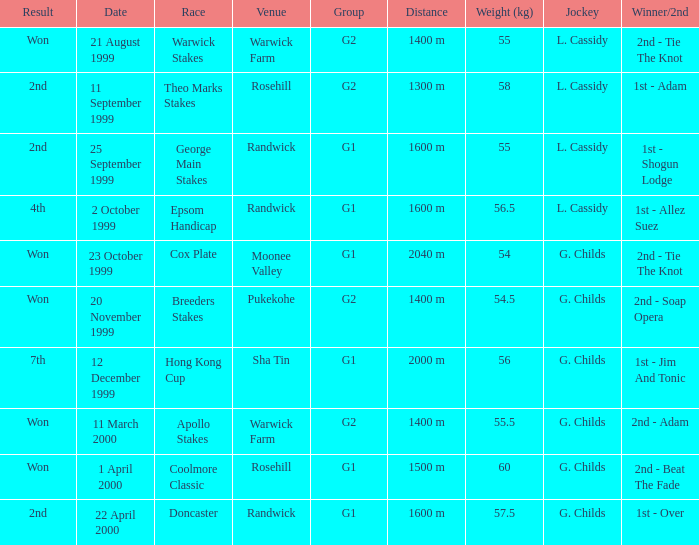List the weight for 56 kilograms. 2000 m. 